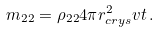<formula> <loc_0><loc_0><loc_500><loc_500>m _ { 2 2 } = \rho _ { 2 2 } 4 \pi r _ { c r y s } ^ { 2 } v t \, .</formula> 